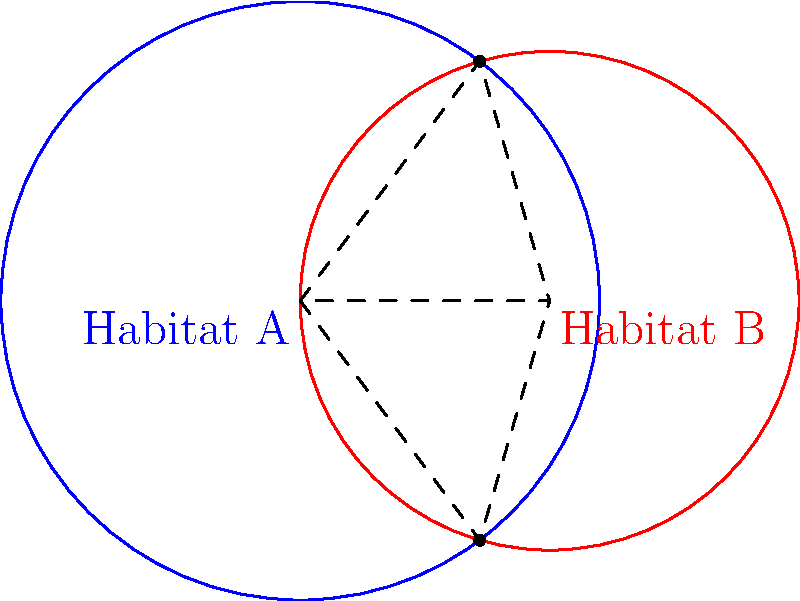In a remote ecosystem, two circular habitat zones are represented by intersecting circles. Habitat A has a radius of 1.2 units, and Habitat B has a radius of 1 unit. The centers of these habitats are 1 unit apart. Calculate the percentage of Habitat B's area that overlaps with Habitat A. Round your answer to the nearest whole percent. To solve this problem, we'll follow these steps:

1) First, we need to calculate the area of overlap between the two circles.

2) The area of overlap can be found using the formula for the area of intersection of two circles:

   $$A = r_1^2 \arccos(\frac{d^2 + r_1^2 - r_2^2}{2dr_1}) + r_2^2 \arccos(\frac{d^2 + r_2^2 - r_1^2}{2dr_2}) - \frac{1}{2}\sqrt{(-d+r_1+r_2)(d+r_1-r_2)(d-r_1+r_2)(d+r_1+r_2)}$$

   Where $r_1$ and $r_2$ are the radii of the circles, and $d$ is the distance between their centers.

3) Let's plug in our values:
   $r_1 = 1.2$, $r_2 = 1$, $d = 1$

4) Calculating:
   $$A = 1.2^2 \arccos(\frac{1^2 + 1.2^2 - 1^2}{2 \cdot 1 \cdot 1.2}) + 1^2 \arccos(\frac{1^2 + 1^2 - 1.2^2}{2 \cdot 1 \cdot 1}) - \frac{1}{2}\sqrt{(-1+1.2+1)(1+1.2-1)(1-1.2+1)(1+1.2+1)}$$

5) This evaluates to approximately 1.0642 square units.

6) Now, we need to calculate the total area of Habitat B:
   $$A_B = \pi r_2^2 = \pi \cdot 1^2 = \pi \approx 3.1416$$

7) The percentage of Habitat B that overlaps with Habitat A is:
   $$\frac{\text{Area of Overlap}}{\text{Area of Habitat B}} \cdot 100\% = \frac{1.0642}{3.1416} \cdot 100\% \approx 33.87\%$$

8) Rounding to the nearest whole percent gives us 34%.
Answer: 34% 